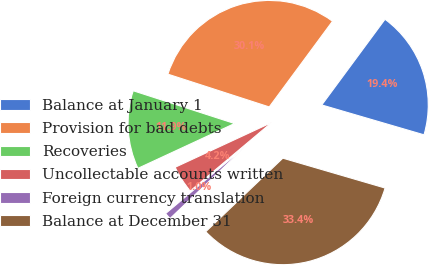Convert chart. <chart><loc_0><loc_0><loc_500><loc_500><pie_chart><fcel>Balance at January 1<fcel>Provision for bad debts<fcel>Recoveries<fcel>Uncollectable accounts written<fcel>Foreign currency translation<fcel>Balance at December 31<nl><fcel>19.4%<fcel>30.14%<fcel>11.89%<fcel>4.21%<fcel>1.0%<fcel>33.35%<nl></chart> 